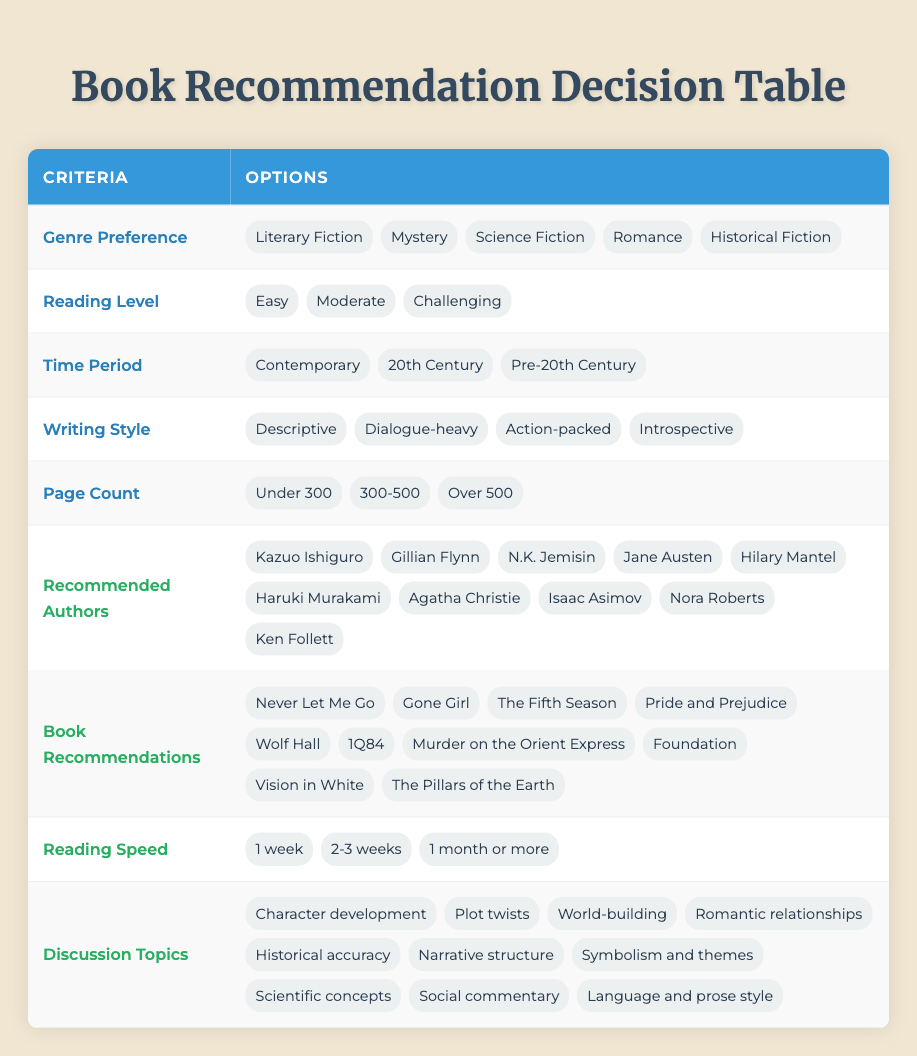What are the options for Genre Preference? The options listed under Genre Preference in the table are Literary Fiction, Mystery, Science Fiction, Romance, and Historical Fiction.
Answer: Literary Fiction, Mystery, Science Fiction, Romance, Historical Fiction Is "Pride and Prejudice" listed as a book recommendation? Yes, "Pride and Prejudice" is included in the list of Book Recommendations in the table.
Answer: Yes How many writing styles are mentioned in the table? There are four writing styles mentioned: Descriptive, Dialogue-heavy, Action-packed, and Introspective, making a total of four styles.
Answer: 4 Which recommended author corresponds to the Mystery genre? For the Mystery genre, the corresponding recommended author is Agatha Christie as she is a well-known writer in that genre.
Answer: Agatha Christie Which genre preference has the highest recommended reading speed? Since no specific reading speed is directly associated with genre preference, one must check if there’s a direct correlation. Given there is no direct indication from the data, it can't be assessed.
Answer: Not applicable If the genre preference is Science Fiction and the reading level is Moderate, which book is a suitable recommendation? Looking at the options provided under Book Recommendations, "Foundation" by Isaac Asimov is a noted work in Science Fiction. Since it matches both criteria, it is a suitable recommendation.
Answer: Foundation Are there more authors recommended for Romance or Historical Fiction? The authors specified in the table do not indicate distinct counts for each genre, hence direct comparison cannot be made based on the provided data. It requires separate counts that are not listed.
Answer: Unable to determine How many discussion topics are available? The table outlines ten different discussion topics, allowing for a rich discussion on various literary aspects.
Answer: 10 Which book recommendation corresponds with a Challenging reading level? "1Q84" by Haruki Murakami is known for its complexity and can be classified under a Challenging reading level. Therefore, it corresponds to that specific level.
Answer: 1Q84 